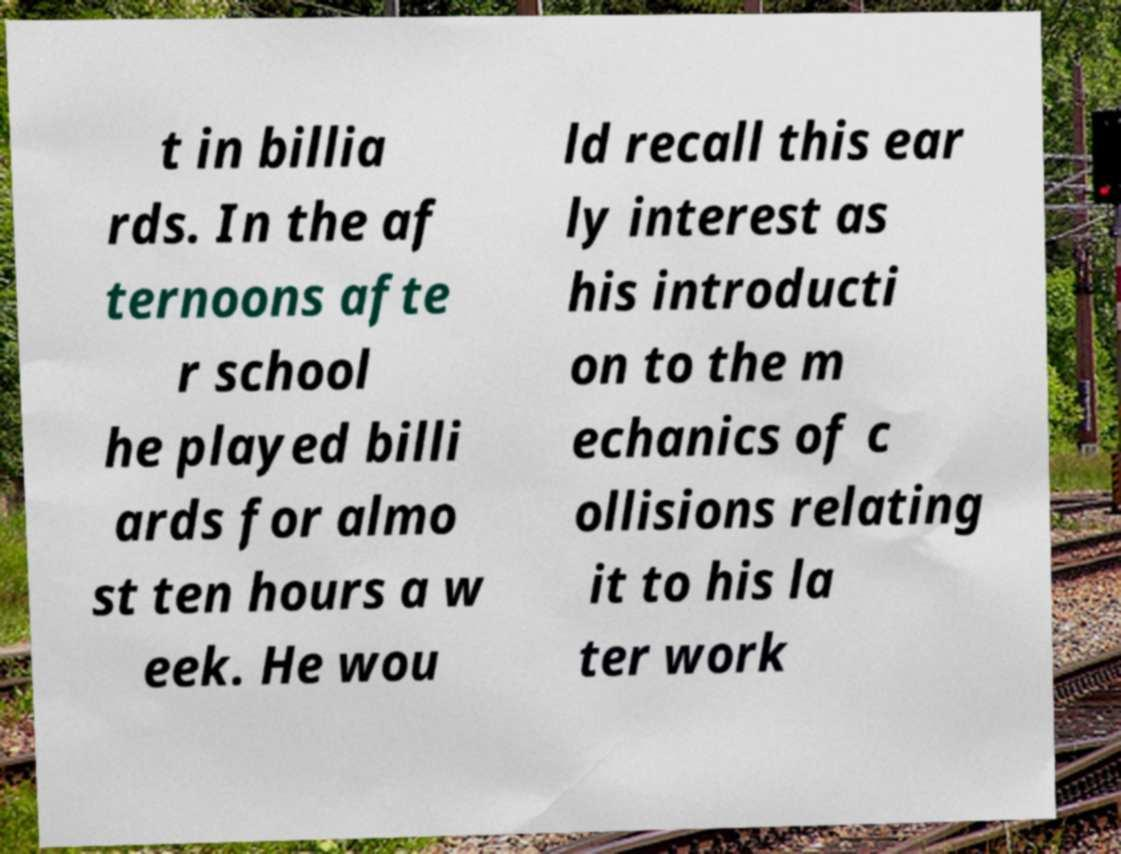I need the written content from this picture converted into text. Can you do that? t in billia rds. In the af ternoons afte r school he played billi ards for almo st ten hours a w eek. He wou ld recall this ear ly interest as his introducti on to the m echanics of c ollisions relating it to his la ter work 